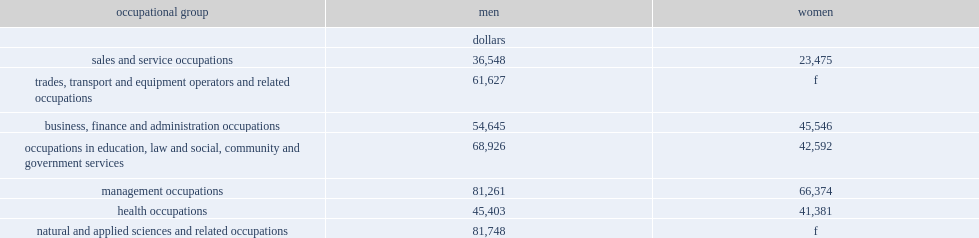What was the the gender pay gap for health occupations? 4022. Among occupations in education, law and social, community and government services,who earned a higher median annual employment income,men or women? Men. 